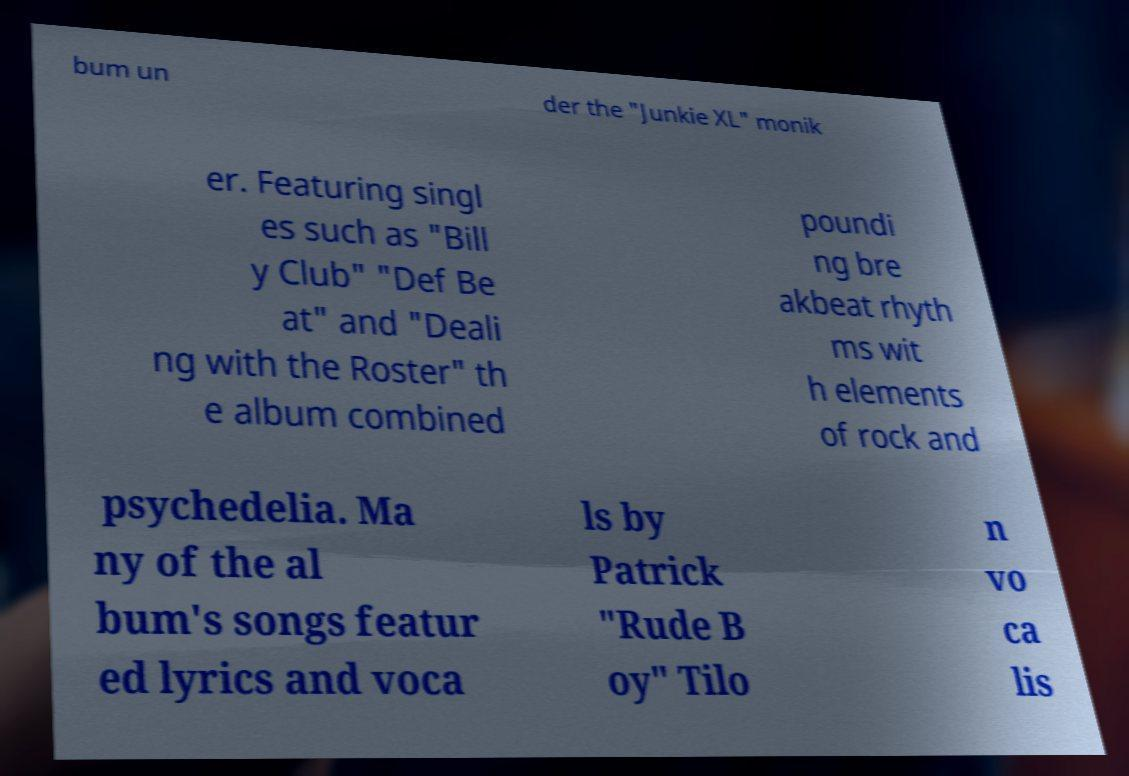Could you assist in decoding the text presented in this image and type it out clearly? bum un der the "Junkie XL" monik er. Featuring singl es such as "Bill y Club" "Def Be at" and "Deali ng with the Roster" th e album combined poundi ng bre akbeat rhyth ms wit h elements of rock and psychedelia. Ma ny of the al bum's songs featur ed lyrics and voca ls by Patrick "Rude B oy" Tilo n vo ca lis 